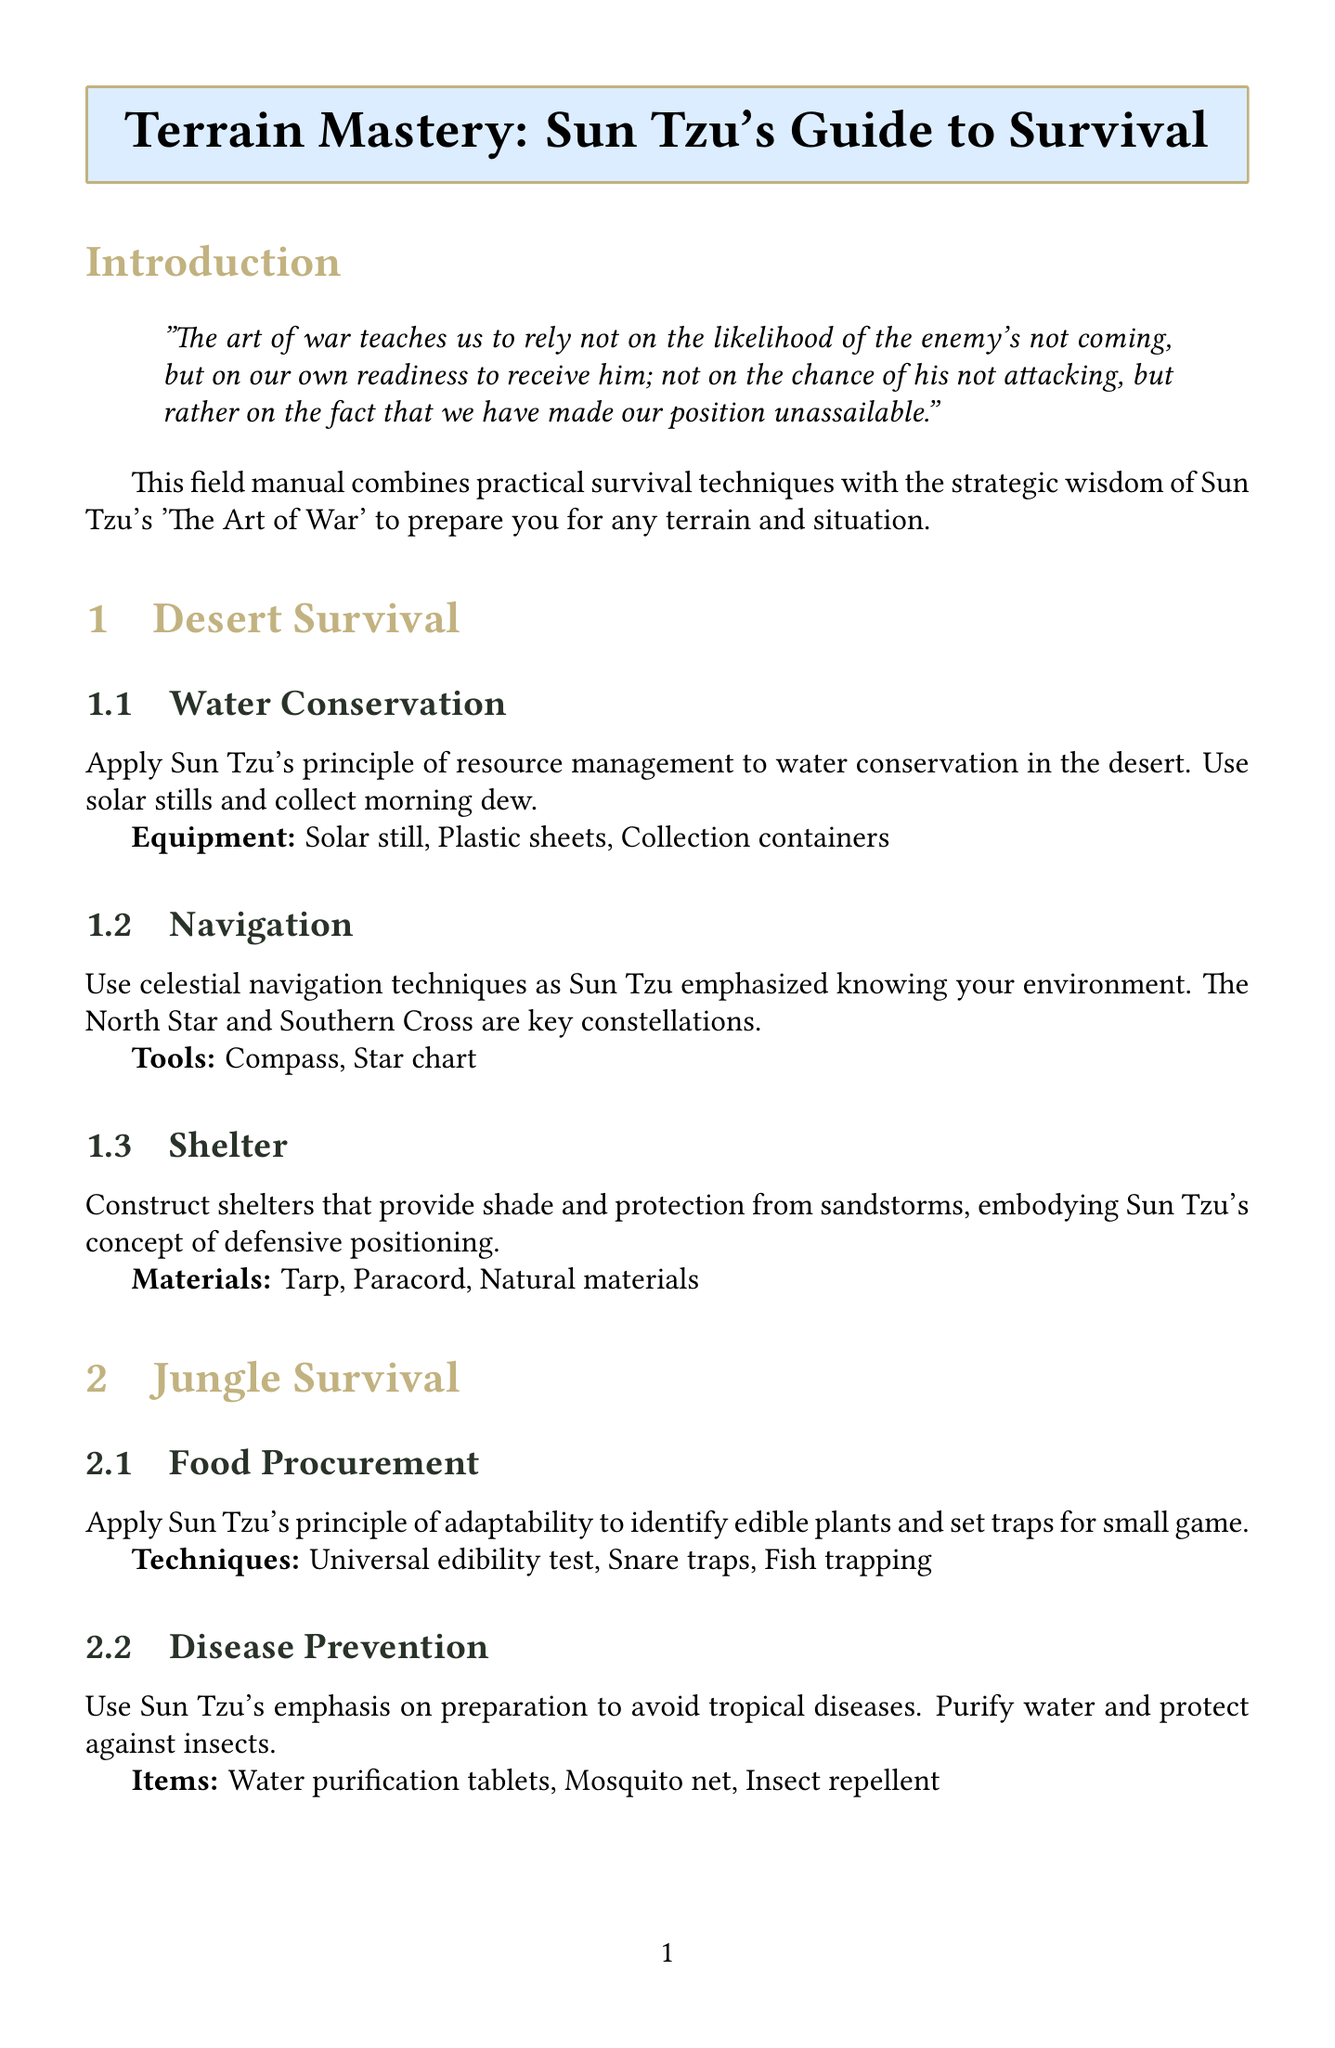What is the title of the manual? The title of the manual is stated prominently at the beginning of the document.
Answer: Terrain Mastery: Sun Tzu's Guide to Survival What terrain is covered in the chapter focused on food procurement? The document specifies that food procurement is addressed in the jungle survival section.
Answer: Jungle How many survival techniques are listed under Arctic Survival? The Arctic Survival section contains three specific techniques as detailed in the document.
Answer: 3 What method is recommended for water purification in the jungle? The document indicates that water purification tablets are essential for disease prevention in the jungle.
Answer: Water purification tablets Which principle does the manual emphasize for navigation in the desert? The navigation in the desert emphasizes Sun Tzu's principle of knowing your environment, illustrated in the document.
Answer: Knowing your environment What type of shelter is advised for desert survival? The manual suggests a type of shelter that provides shade and protection from sandstorms.
Answer: Shelters that provide shade Which tactic is suggested for avoiding predators in Arctic survival? The document recommends proper food storage as a tactic to avoid predators like polar bears and wolves.
Answer: Proper food storage What is the concluding quote of the manual? The final quote encapsulates a key principle from Sun Tzu related to warfare and survival.
Answer: Victorious warriors win first and then go to war, while defeated warriors go to war first and then seek to win 